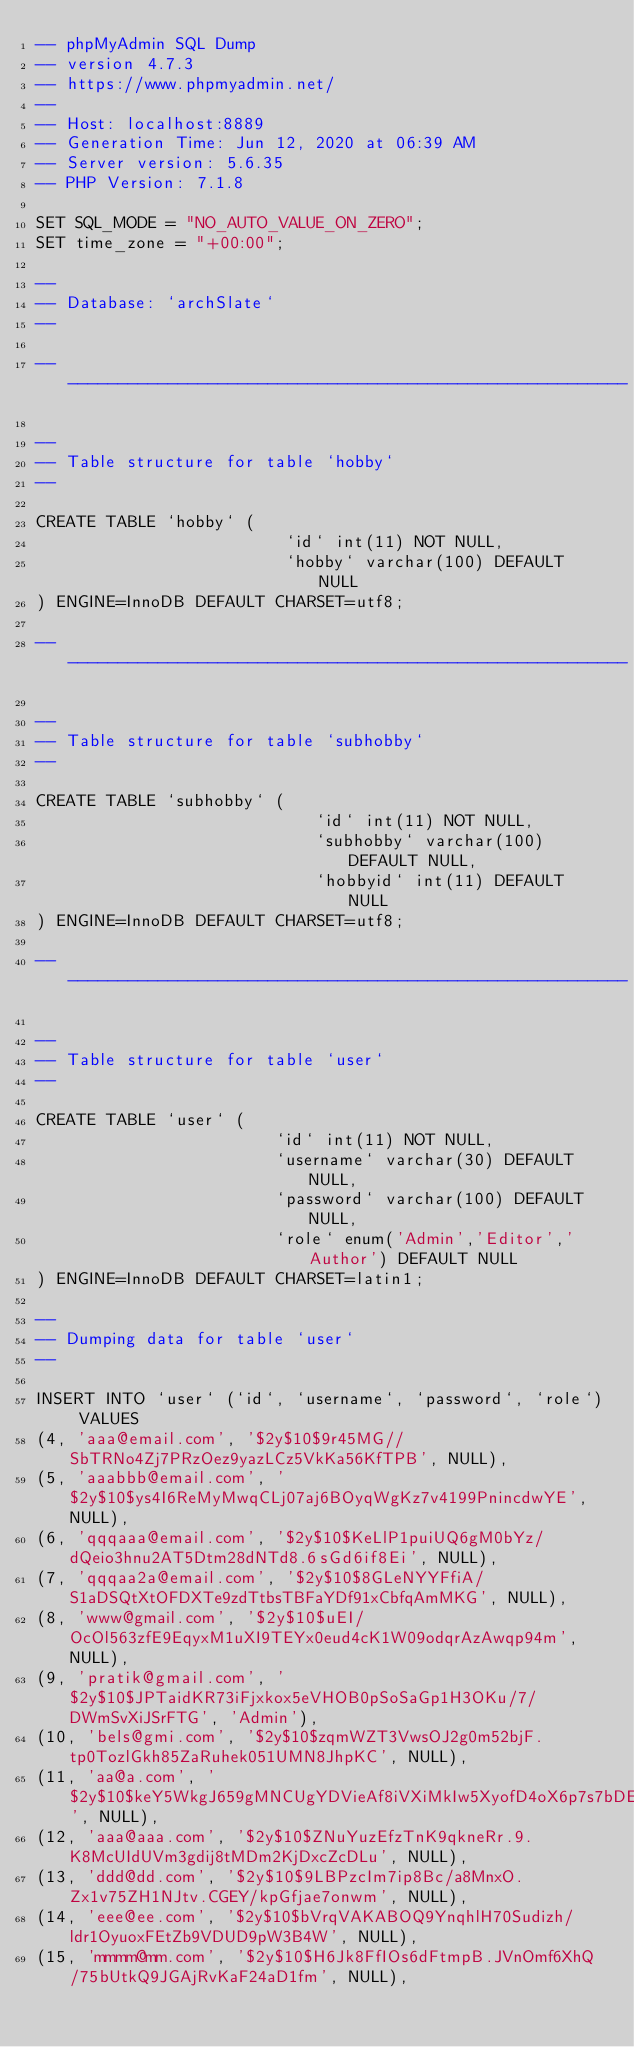<code> <loc_0><loc_0><loc_500><loc_500><_SQL_>-- phpMyAdmin SQL Dump
-- version 4.7.3
-- https://www.phpmyadmin.net/
--
-- Host: localhost:8889
-- Generation Time: Jun 12, 2020 at 06:39 AM
-- Server version: 5.6.35
-- PHP Version: 7.1.8

SET SQL_MODE = "NO_AUTO_VALUE_ON_ZERO";
SET time_zone = "+00:00";

--
-- Database: `archSlate`
--

-- --------------------------------------------------------

--
-- Table structure for table `hobby`
--

CREATE TABLE `hobby` (
                         `id` int(11) NOT NULL,
                         `hobby` varchar(100) DEFAULT NULL
) ENGINE=InnoDB DEFAULT CHARSET=utf8;

-- --------------------------------------------------------

--
-- Table structure for table `subhobby`
--

CREATE TABLE `subhobby` (
                            `id` int(11) NOT NULL,
                            `subhobby` varchar(100) DEFAULT NULL,
                            `hobbyid` int(11) DEFAULT NULL
) ENGINE=InnoDB DEFAULT CHARSET=utf8;

-- --------------------------------------------------------

--
-- Table structure for table `user`
--

CREATE TABLE `user` (
                        `id` int(11) NOT NULL,
                        `username` varchar(30) DEFAULT NULL,
                        `password` varchar(100) DEFAULT NULL,
                        `role` enum('Admin','Editor','Author') DEFAULT NULL
) ENGINE=InnoDB DEFAULT CHARSET=latin1;

--
-- Dumping data for table `user`
--

INSERT INTO `user` (`id`, `username`, `password`, `role`) VALUES
(4, 'aaa@email.com', '$2y$10$9r45MG//SbTRNo4Zj7PRzOez9yazLCz5VkKa56KfTPB', NULL),
(5, 'aaabbb@email.com', '$2y$10$ys4I6ReMyMwqCLj07aj6BOyqWgKz7v4199PnincdwYE', NULL),
(6, 'qqqaaa@email.com', '$2y$10$KeLlP1puiUQ6gM0bYz/dQeio3hnu2AT5Dtm28dNTd8.6sGd6if8Ei', NULL),
(7, 'qqqaa2a@email.com', '$2y$10$8GLeNYYFfiA/S1aDSQtXtOFDXTe9zdTtbsTBFaYDf91xCbfqAmMKG', NULL),
(8, 'www@gmail.com', '$2y$10$uEI/OcOl563zfE9EqyxM1uXI9TEYx0eud4cK1W09odqrAzAwqp94m', NULL),
(9, 'pratik@gmail.com', '$2y$10$JPTaidKR73iFjxkox5eVHOB0pSoSaGp1H3OKu/7/DWmSvXiJSrFTG', 'Admin'),
(10, 'bels@gmi.com', '$2y$10$zqmWZT3VwsOJ2g0m52bjF.tp0TozlGkh85ZaRuhek051UMN8JhpKC', NULL),
(11, 'aa@a.com', '$2y$10$keY5WkgJ659gMNCUgYDVieAf8iVXiMkIw5XyofD4oX6p7s7bDElVK', NULL),
(12, 'aaa@aaa.com', '$2y$10$ZNuYuzEfzTnK9qkneRr.9.K8McUIdUVm3gdij8tMDm2KjDxcZcDLu', NULL),
(13, 'ddd@dd.com', '$2y$10$9LBPzcIm7ip8Bc/a8MnxO.Zx1v75ZH1NJtv.CGEY/kpGfjae7onwm', NULL),
(14, 'eee@ee.com', '$2y$10$bVrqVAKABOQ9YnqhlH70Sudizh/ldr1OyuoxFEtZb9VDUD9pW3B4W', NULL),
(15, 'mmmm@mm.com', '$2y$10$H6Jk8FfIOs6dFtmpB.JVnOmf6XhQ/75bUtkQ9JGAjRvKaF24aD1fm', NULL),</code> 